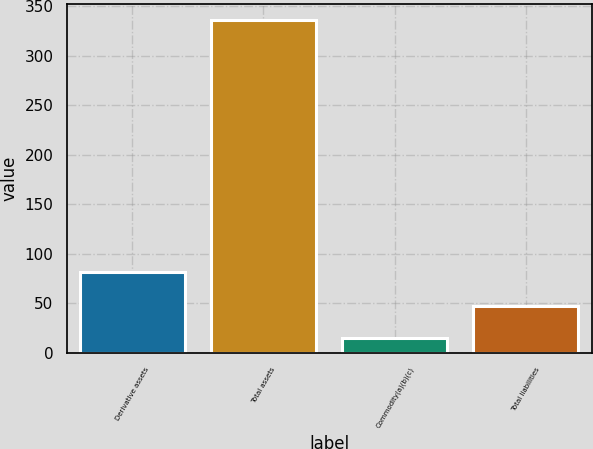<chart> <loc_0><loc_0><loc_500><loc_500><bar_chart><fcel>Derivative assets<fcel>Total assets<fcel>Commodity(a)(b)(c)<fcel>Total liabilities<nl><fcel>82<fcel>336<fcel>15<fcel>47.1<nl></chart> 